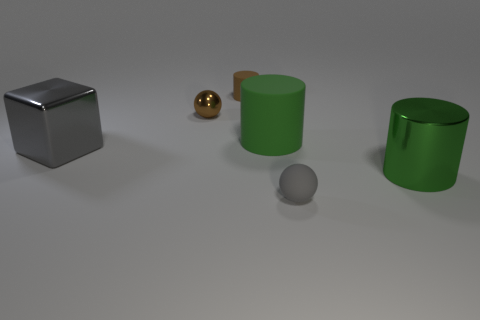The thing that is the same color as the large block is what size?
Offer a terse response. Small. What is the size of the ball that is made of the same material as the brown cylinder?
Give a very brief answer. Small. What is the shape of the matte object that is the same color as the cube?
Your response must be concise. Sphere. What number of tiny objects are either purple metallic objects or gray matte spheres?
Your answer should be compact. 1. There is a metal object on the left side of the metallic sphere; is its shape the same as the green matte object?
Keep it short and to the point. No. Are there fewer tiny rubber objects than small brown matte cylinders?
Provide a short and direct response. No. Is there any other thing that has the same color as the big metallic cube?
Provide a succinct answer. Yes. The gray object that is right of the tiny brown rubber cylinder has what shape?
Your answer should be very brief. Sphere. Do the large metal cylinder and the large cylinder behind the metallic block have the same color?
Ensure brevity in your answer.  Yes. Is the number of big matte cylinders in front of the tiny gray thing the same as the number of tiny gray rubber objects in front of the big gray metallic thing?
Your answer should be very brief. No. 